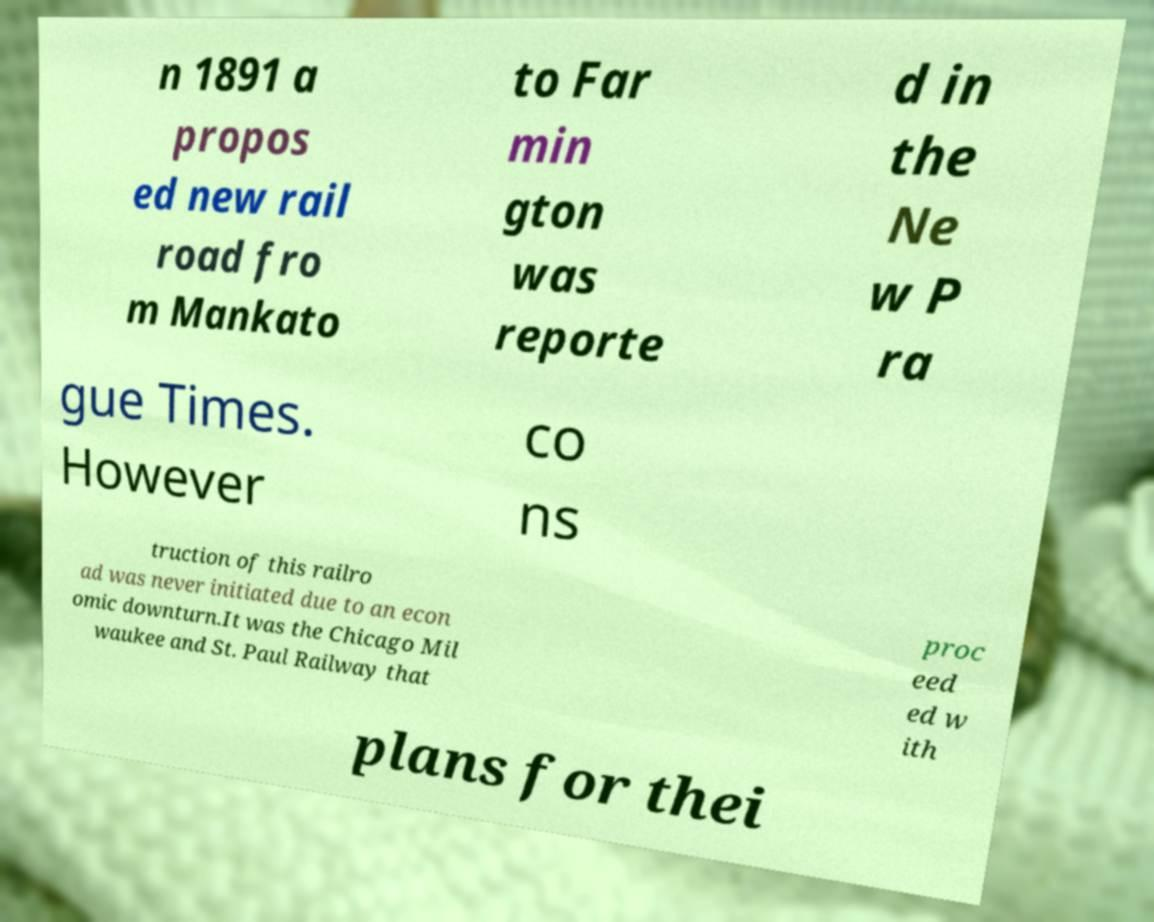Can you read and provide the text displayed in the image?This photo seems to have some interesting text. Can you extract and type it out for me? n 1891 a propos ed new rail road fro m Mankato to Far min gton was reporte d in the Ne w P ra gue Times. However co ns truction of this railro ad was never initiated due to an econ omic downturn.It was the Chicago Mil waukee and St. Paul Railway that proc eed ed w ith plans for thei 